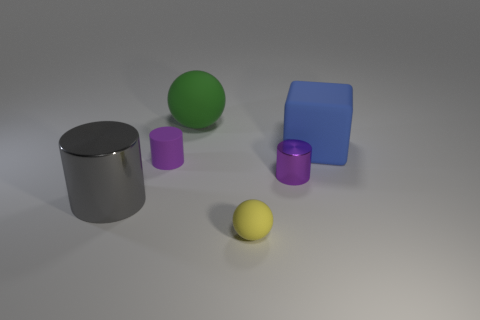Subtract all shiny cylinders. How many cylinders are left? 1 Subtract all gray cylinders. How many cylinders are left? 2 Subtract 1 cubes. How many cubes are left? 0 Add 1 tiny things. How many objects exist? 7 Subtract all purple cylinders. Subtract all red cubes. How many cylinders are left? 1 Subtract all purple metal cylinders. Subtract all purple cylinders. How many objects are left? 3 Add 2 gray metal things. How many gray metal things are left? 3 Add 2 purple blocks. How many purple blocks exist? 2 Subtract 0 gray cubes. How many objects are left? 6 Subtract all cubes. How many objects are left? 5 